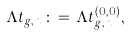Convert formula to latex. <formula><loc_0><loc_0><loc_500><loc_500>\Lambda t _ { g , n } \, \colon = \, \Lambda t _ { g , n } ^ { ( 0 , 0 ) } ,</formula> 